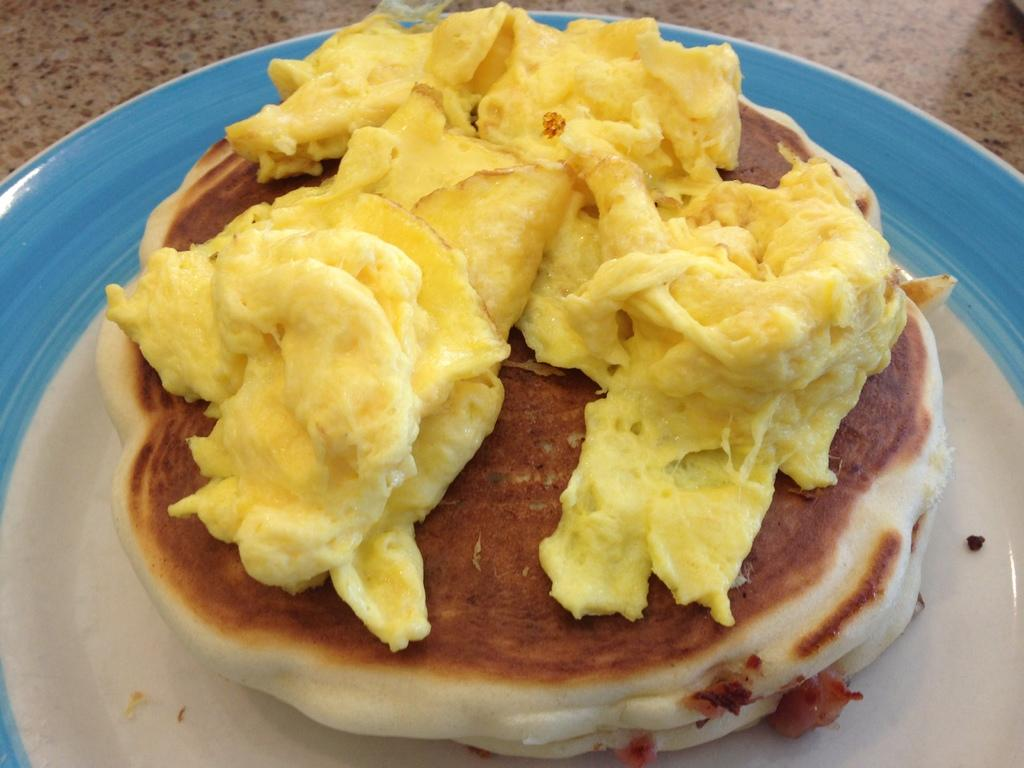What is on the plate that is visible in the image? The plate contains bread and cheese. Where is the plate located in the image? The plate is on a table. What color is the balloon that is floating above the plate in the image? There is no balloon present in the image; the plate contains bread and cheese on a table. 